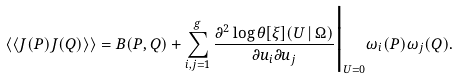<formula> <loc_0><loc_0><loc_500><loc_500>\langle \langle J ( P ) J ( Q ) \rangle \rangle = B ( P , Q ) + \sum _ { i , j = 1 } ^ { g } \frac { \partial ^ { 2 } \log \theta [ \xi ] ( U \, | \, \Omega ) } { \partial u _ { i } \partial u _ { j } } \Big | _ { U = 0 } \omega _ { i } ( P ) \omega _ { j } ( Q ) .</formula> 